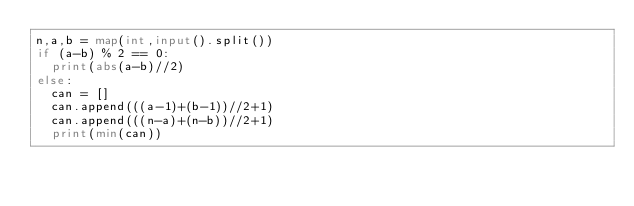Convert code to text. <code><loc_0><loc_0><loc_500><loc_500><_Python_>n,a,b = map(int,input().split())
if (a-b) % 2 == 0:
  print(abs(a-b)//2)
else:
  can = []
  can.append(((a-1)+(b-1))//2+1)
  can.append(((n-a)+(n-b))//2+1)
  print(min(can))</code> 